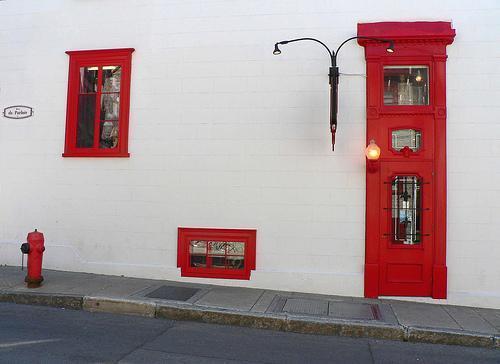How many doors are in the photo?
Give a very brief answer. 1. How many purple fire hydrants are in the picture?
Give a very brief answer. 0. 